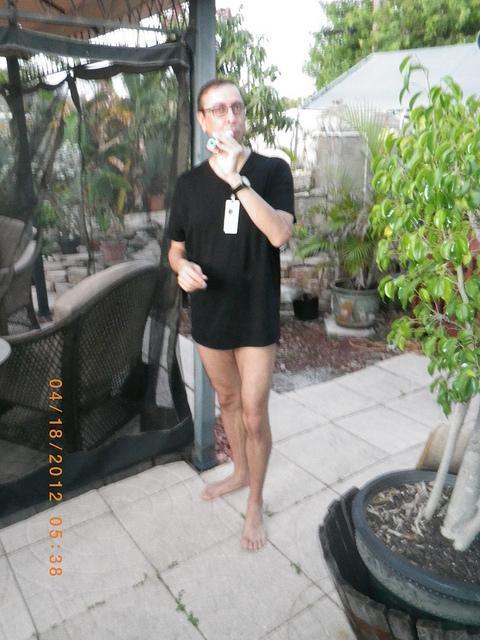Who is likely taking this picture in relation to the person who poses?
Select the accurate response from the four choices given to answer the question.
Options: Enemy, spy, news team, intimate friend. Intimate friend. 